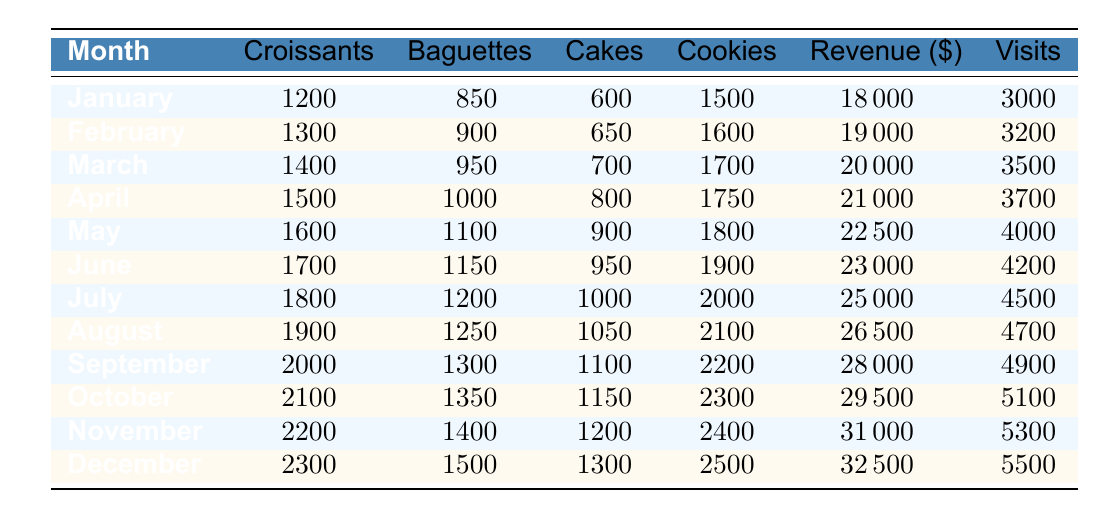What was the total revenue in December? In December, the total revenue is explicitly listed in the table as $32,500.
Answer: 32500 How many croissants were sold in August? The table shows that in August, 1,900 croissants were sold.
Answer: 1900 Which month had the highest customer visits? The highest number of customer visits is in December with 5,500 visits according to the table.
Answer: 5500 What is the sum of cookies sold in January and February? According to the table, cookies sold in January were 1,500 and in February were 1,600. Summing these gives 1,500 + 1,600 = 3,100.
Answer: 3100 How many more baguettes were sold in November than in May? In November, 1,400 baguettes were sold and in May, 1,100. The difference is 1,400 - 1,100 = 300.
Answer: 300 What is the average number of cakes sold over the year? Adding the cakes sold from each month: 600 + 650 + 700 + 800 + 900 + 950 + 1000 + 1050 + 1100 + 1150 + 1200 + 1300 = 12,600. Since there are 12 months, the average is 12,600 / 12 = 1,050.
Answer: 1050 Did the sales of croissants increase every month? The table shows a consistent increase in croissant sales each month from January (1,200) to December (2,300), confirming the sales increased every month.
Answer: Yes What was the total number of cookies sold in the first half of the year (January to June)? The cookies sold from January to June are: 1,500 (Jan) + 1,600 (Feb) + 1,700 (Mar) + 1,750 (Apr) + 1,800 (May) + 1,900 (Jun) = 10,250 cookies.
Answer: 10250 Which month had the second highest total revenue? Looking at the revenue figures, November had $31,000, and October had $29,500. Since November is higher than October, November is the second highest following December's $32,500.
Answer: November How much did the total revenue increase from July to August? The total revenue in July is $25,000 and in August is $26,500. The increase is $26,500 - $25,000 = $1,500.
Answer: 1500 